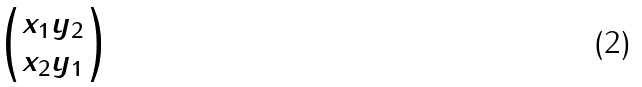Convert formula to latex. <formula><loc_0><loc_0><loc_500><loc_500>\begin{pmatrix} x _ { 1 } y _ { 2 } \\ x _ { 2 } y _ { 1 } \end{pmatrix}</formula> 